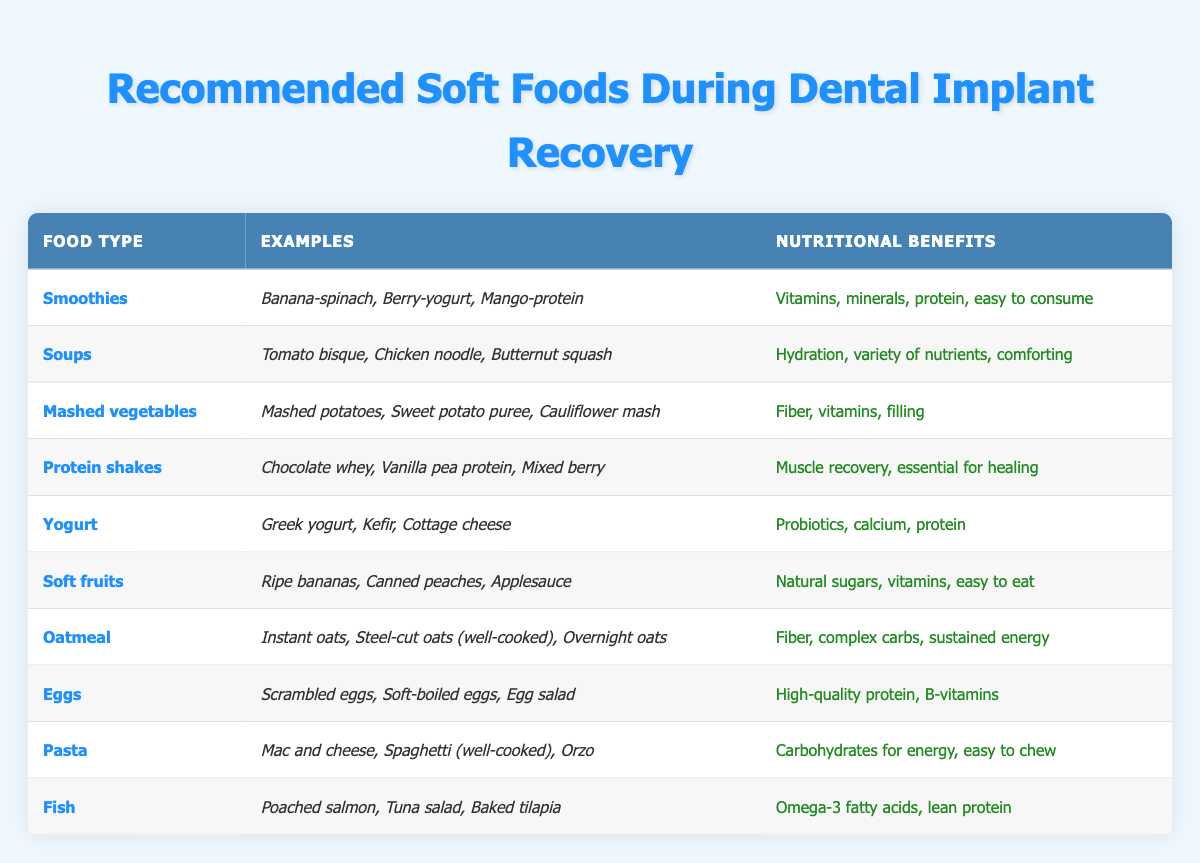What are two examples of soups recommended during recovery? The table lists "Tomato bisque" and "Chicken noodle" as examples of soups recommended during recovery.
Answer: Tomato bisque, Chicken noodle Which food type provides high-quality protein and B-vitamins? Looking at the table, "Eggs" are mentioned as providing high-quality protein and B-vitamins.
Answer: Eggs Does oatmeal offer hydration? The table does not mention hydration under oatmeal; it states that it provides fiber, complex carbs, and sustained energy, so the answer is no.
Answer: No How many food types listed offer natural sugars? The food type "Soft fruits" is the only one that specifies natural sugars directly while mentioning "rijpe bananas, canned peaches, applesauce," indicating just one food type.
Answer: 1 What are the nutritional benefits of protein shakes? According to the table, protein shakes provide muscle recovery and are essential for healing.
Answer: Muscle recovery, essential for healing Which food type is associated with omega-3 fatty acids? The table states that "Fish" provides omega-3 fatty acids, as indicated in its description.
Answer: Fish Compare the number of food types that have vitamins in their nutritional benefits versus those that mention energy. Food types with vitamins include "Smoothies," "Mashed vegetables," "Yogurt," "Soft fruits," "Eggs," while "Oatmeal" and "Pasta" mention energy. Counting gives 5 food types with vitamins and 3 food types related to energy, hence the difference is 5-3 = 2.
Answer: 2 Which food type has the most examples listed? Examining the table, each food type generally has 3 examples listed. Therefore, they are equally presented, as no food type has more than this.
Answer: All food types have an equal number of examples Do smoothies aid in easy consumption? The table explicitly states that smoothies are easy to consume among their nutritional benefits, confirming that this fact is true.
Answer: Yes 